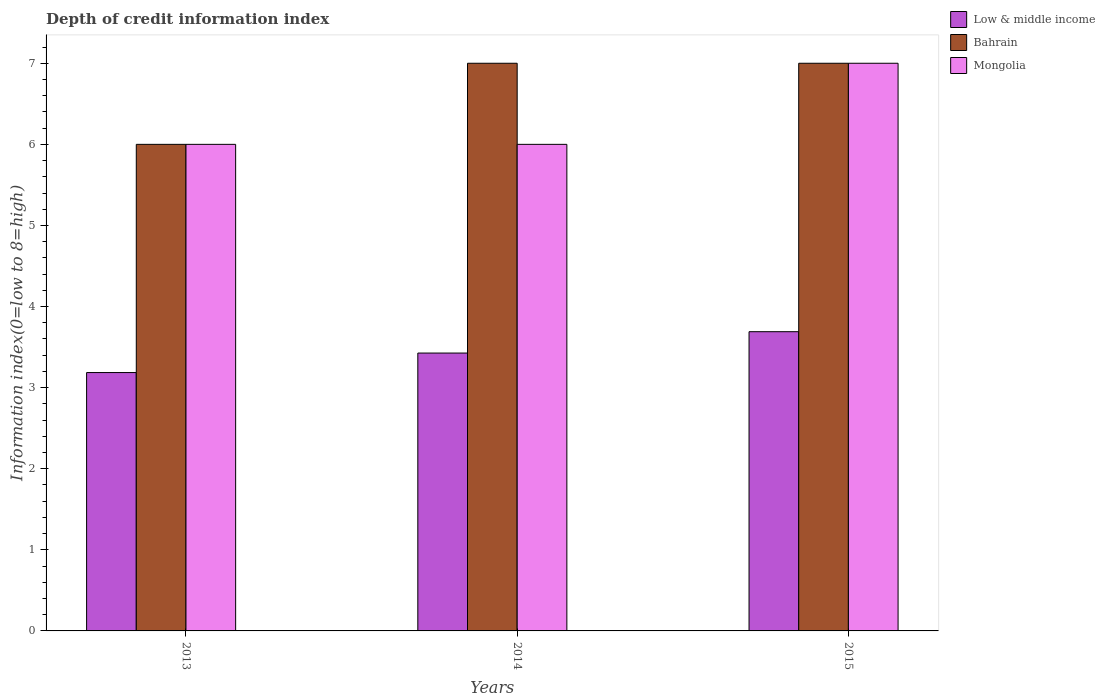Are the number of bars per tick equal to the number of legend labels?
Ensure brevity in your answer.  Yes. Are the number of bars on each tick of the X-axis equal?
Give a very brief answer. Yes. How many bars are there on the 1st tick from the left?
Your answer should be very brief. 3. How many bars are there on the 3rd tick from the right?
Provide a succinct answer. 3. What is the label of the 1st group of bars from the left?
Ensure brevity in your answer.  2013. In how many cases, is the number of bars for a given year not equal to the number of legend labels?
Provide a short and direct response. 0. What is the information index in Low & middle income in 2015?
Provide a succinct answer. 3.69. Across all years, what is the maximum information index in Low & middle income?
Keep it short and to the point. 3.69. Across all years, what is the minimum information index in Bahrain?
Keep it short and to the point. 6. In which year was the information index in Mongolia maximum?
Your answer should be very brief. 2015. What is the total information index in Mongolia in the graph?
Your response must be concise. 19. What is the difference between the information index in Bahrain in 2013 and that in 2014?
Ensure brevity in your answer.  -1. What is the difference between the information index in Bahrain in 2015 and the information index in Mongolia in 2014?
Give a very brief answer. 1. What is the average information index in Low & middle income per year?
Your response must be concise. 3.43. In the year 2015, what is the difference between the information index in Bahrain and information index in Low & middle income?
Ensure brevity in your answer.  3.31. In how many years, is the information index in Mongolia greater than 2.4?
Offer a very short reply. 3. What is the ratio of the information index in Low & middle income in 2014 to that in 2015?
Make the answer very short. 0.93. Is the information index in Low & middle income in 2014 less than that in 2015?
Provide a succinct answer. Yes. What is the difference between the highest and the second highest information index in Mongolia?
Keep it short and to the point. 1. What is the difference between the highest and the lowest information index in Bahrain?
Give a very brief answer. 1. In how many years, is the information index in Bahrain greater than the average information index in Bahrain taken over all years?
Your response must be concise. 2. What does the 3rd bar from the left in 2015 represents?
Keep it short and to the point. Mongolia. What does the 2nd bar from the right in 2015 represents?
Your response must be concise. Bahrain. How many bars are there?
Ensure brevity in your answer.  9. Are all the bars in the graph horizontal?
Your response must be concise. No. What is the difference between two consecutive major ticks on the Y-axis?
Provide a succinct answer. 1. Where does the legend appear in the graph?
Give a very brief answer. Top right. What is the title of the graph?
Offer a very short reply. Depth of credit information index. Does "Nepal" appear as one of the legend labels in the graph?
Your response must be concise. No. What is the label or title of the X-axis?
Provide a succinct answer. Years. What is the label or title of the Y-axis?
Your answer should be compact. Information index(0=low to 8=high). What is the Information index(0=low to 8=high) of Low & middle income in 2013?
Offer a terse response. 3.19. What is the Information index(0=low to 8=high) in Low & middle income in 2014?
Make the answer very short. 3.43. What is the Information index(0=low to 8=high) in Bahrain in 2014?
Your response must be concise. 7. What is the Information index(0=low to 8=high) in Mongolia in 2014?
Provide a short and direct response. 6. What is the Information index(0=low to 8=high) of Low & middle income in 2015?
Make the answer very short. 3.69. What is the Information index(0=low to 8=high) in Mongolia in 2015?
Provide a short and direct response. 7. Across all years, what is the maximum Information index(0=low to 8=high) of Low & middle income?
Provide a short and direct response. 3.69. Across all years, what is the minimum Information index(0=low to 8=high) in Low & middle income?
Provide a succinct answer. 3.19. Across all years, what is the minimum Information index(0=low to 8=high) of Bahrain?
Offer a very short reply. 6. What is the total Information index(0=low to 8=high) in Low & middle income in the graph?
Your answer should be compact. 10.3. What is the difference between the Information index(0=low to 8=high) of Low & middle income in 2013 and that in 2014?
Give a very brief answer. -0.24. What is the difference between the Information index(0=low to 8=high) in Low & middle income in 2013 and that in 2015?
Provide a short and direct response. -0.5. What is the difference between the Information index(0=low to 8=high) in Bahrain in 2013 and that in 2015?
Offer a terse response. -1. What is the difference between the Information index(0=low to 8=high) in Low & middle income in 2014 and that in 2015?
Your response must be concise. -0.26. What is the difference between the Information index(0=low to 8=high) in Bahrain in 2014 and that in 2015?
Your answer should be very brief. 0. What is the difference between the Information index(0=low to 8=high) in Mongolia in 2014 and that in 2015?
Provide a succinct answer. -1. What is the difference between the Information index(0=low to 8=high) in Low & middle income in 2013 and the Information index(0=low to 8=high) in Bahrain in 2014?
Keep it short and to the point. -3.81. What is the difference between the Information index(0=low to 8=high) in Low & middle income in 2013 and the Information index(0=low to 8=high) in Mongolia in 2014?
Make the answer very short. -2.81. What is the difference between the Information index(0=low to 8=high) of Bahrain in 2013 and the Information index(0=low to 8=high) of Mongolia in 2014?
Your answer should be very brief. 0. What is the difference between the Information index(0=low to 8=high) of Low & middle income in 2013 and the Information index(0=low to 8=high) of Bahrain in 2015?
Your answer should be very brief. -3.81. What is the difference between the Information index(0=low to 8=high) in Low & middle income in 2013 and the Information index(0=low to 8=high) in Mongolia in 2015?
Make the answer very short. -3.81. What is the difference between the Information index(0=low to 8=high) of Bahrain in 2013 and the Information index(0=low to 8=high) of Mongolia in 2015?
Make the answer very short. -1. What is the difference between the Information index(0=low to 8=high) of Low & middle income in 2014 and the Information index(0=low to 8=high) of Bahrain in 2015?
Make the answer very short. -3.57. What is the difference between the Information index(0=low to 8=high) of Low & middle income in 2014 and the Information index(0=low to 8=high) of Mongolia in 2015?
Your answer should be compact. -3.57. What is the average Information index(0=low to 8=high) of Low & middle income per year?
Provide a short and direct response. 3.43. What is the average Information index(0=low to 8=high) in Mongolia per year?
Your response must be concise. 6.33. In the year 2013, what is the difference between the Information index(0=low to 8=high) of Low & middle income and Information index(0=low to 8=high) of Bahrain?
Your response must be concise. -2.81. In the year 2013, what is the difference between the Information index(0=low to 8=high) of Low & middle income and Information index(0=low to 8=high) of Mongolia?
Provide a short and direct response. -2.81. In the year 2013, what is the difference between the Information index(0=low to 8=high) of Bahrain and Information index(0=low to 8=high) of Mongolia?
Make the answer very short. 0. In the year 2014, what is the difference between the Information index(0=low to 8=high) in Low & middle income and Information index(0=low to 8=high) in Bahrain?
Ensure brevity in your answer.  -3.57. In the year 2014, what is the difference between the Information index(0=low to 8=high) in Low & middle income and Information index(0=low to 8=high) in Mongolia?
Offer a terse response. -2.57. In the year 2015, what is the difference between the Information index(0=low to 8=high) in Low & middle income and Information index(0=low to 8=high) in Bahrain?
Your response must be concise. -3.31. In the year 2015, what is the difference between the Information index(0=low to 8=high) of Low & middle income and Information index(0=low to 8=high) of Mongolia?
Ensure brevity in your answer.  -3.31. In the year 2015, what is the difference between the Information index(0=low to 8=high) in Bahrain and Information index(0=low to 8=high) in Mongolia?
Offer a terse response. 0. What is the ratio of the Information index(0=low to 8=high) in Low & middle income in 2013 to that in 2014?
Your answer should be very brief. 0.93. What is the ratio of the Information index(0=low to 8=high) of Bahrain in 2013 to that in 2014?
Keep it short and to the point. 0.86. What is the ratio of the Information index(0=low to 8=high) in Low & middle income in 2013 to that in 2015?
Give a very brief answer. 0.86. What is the ratio of the Information index(0=low to 8=high) of Low & middle income in 2014 to that in 2015?
Your response must be concise. 0.93. What is the ratio of the Information index(0=low to 8=high) in Bahrain in 2014 to that in 2015?
Make the answer very short. 1. What is the ratio of the Information index(0=low to 8=high) in Mongolia in 2014 to that in 2015?
Your answer should be very brief. 0.86. What is the difference between the highest and the second highest Information index(0=low to 8=high) in Low & middle income?
Give a very brief answer. 0.26. What is the difference between the highest and the second highest Information index(0=low to 8=high) of Bahrain?
Your response must be concise. 0. What is the difference between the highest and the lowest Information index(0=low to 8=high) of Low & middle income?
Your answer should be compact. 0.5. What is the difference between the highest and the lowest Information index(0=low to 8=high) in Bahrain?
Your answer should be compact. 1. What is the difference between the highest and the lowest Information index(0=low to 8=high) of Mongolia?
Provide a short and direct response. 1. 